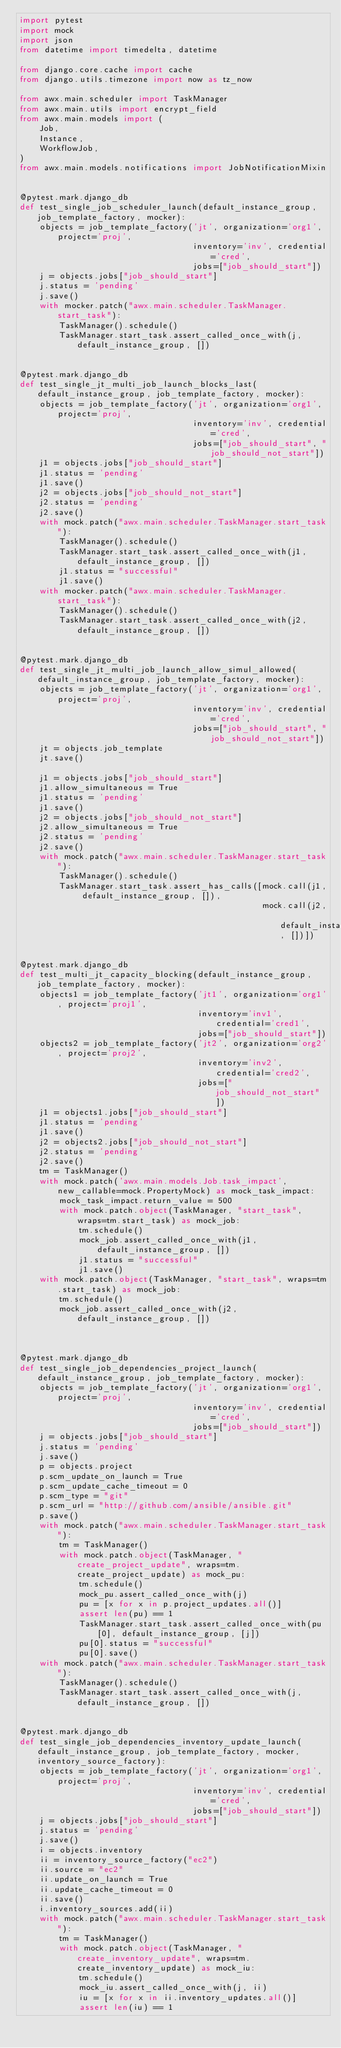<code> <loc_0><loc_0><loc_500><loc_500><_Python_>import pytest
import mock
import json
from datetime import timedelta, datetime

from django.core.cache import cache
from django.utils.timezone import now as tz_now

from awx.main.scheduler import TaskManager
from awx.main.utils import encrypt_field
from awx.main.models import (
    Job,
    Instance,
    WorkflowJob,
)
from awx.main.models.notifications import JobNotificationMixin


@pytest.mark.django_db
def test_single_job_scheduler_launch(default_instance_group, job_template_factory, mocker):
    objects = job_template_factory('jt', organization='org1', project='proj',
                                   inventory='inv', credential='cred',
                                   jobs=["job_should_start"])
    j = objects.jobs["job_should_start"]
    j.status = 'pending'
    j.save()
    with mocker.patch("awx.main.scheduler.TaskManager.start_task"):
        TaskManager().schedule()
        TaskManager.start_task.assert_called_once_with(j, default_instance_group, [])


@pytest.mark.django_db
def test_single_jt_multi_job_launch_blocks_last(default_instance_group, job_template_factory, mocker):
    objects = job_template_factory('jt', organization='org1', project='proj',
                                   inventory='inv', credential='cred',
                                   jobs=["job_should_start", "job_should_not_start"])
    j1 = objects.jobs["job_should_start"]
    j1.status = 'pending'
    j1.save()
    j2 = objects.jobs["job_should_not_start"]
    j2.status = 'pending'
    j2.save()
    with mock.patch("awx.main.scheduler.TaskManager.start_task"):
        TaskManager().schedule()
        TaskManager.start_task.assert_called_once_with(j1, default_instance_group, [])
        j1.status = "successful"
        j1.save()
    with mocker.patch("awx.main.scheduler.TaskManager.start_task"):
        TaskManager().schedule()
        TaskManager.start_task.assert_called_once_with(j2, default_instance_group, [])


@pytest.mark.django_db
def test_single_jt_multi_job_launch_allow_simul_allowed(default_instance_group, job_template_factory, mocker):
    objects = job_template_factory('jt', organization='org1', project='proj',
                                   inventory='inv', credential='cred',
                                   jobs=["job_should_start", "job_should_not_start"])
    jt = objects.job_template
    jt.save()

    j1 = objects.jobs["job_should_start"]
    j1.allow_simultaneous = True
    j1.status = 'pending'
    j1.save()
    j2 = objects.jobs["job_should_not_start"]
    j2.allow_simultaneous = True
    j2.status = 'pending'
    j2.save()
    with mock.patch("awx.main.scheduler.TaskManager.start_task"):
        TaskManager().schedule()
        TaskManager.start_task.assert_has_calls([mock.call(j1, default_instance_group, []),
                                                 mock.call(j2, default_instance_group, [])])


@pytest.mark.django_db
def test_multi_jt_capacity_blocking(default_instance_group, job_template_factory, mocker):
    objects1 = job_template_factory('jt1', organization='org1', project='proj1',
                                    inventory='inv1', credential='cred1',
                                    jobs=["job_should_start"])
    objects2 = job_template_factory('jt2', organization='org2', project='proj2',
                                    inventory='inv2', credential='cred2',
                                    jobs=["job_should_not_start"])
    j1 = objects1.jobs["job_should_start"]
    j1.status = 'pending'
    j1.save()
    j2 = objects2.jobs["job_should_not_start"]
    j2.status = 'pending'
    j2.save()
    tm = TaskManager()
    with mock.patch('awx.main.models.Job.task_impact', new_callable=mock.PropertyMock) as mock_task_impact:
        mock_task_impact.return_value = 500
        with mock.patch.object(TaskManager, "start_task", wraps=tm.start_task) as mock_job:
            tm.schedule()
            mock_job.assert_called_once_with(j1, default_instance_group, [])
            j1.status = "successful"
            j1.save()
    with mock.patch.object(TaskManager, "start_task", wraps=tm.start_task) as mock_job:
        tm.schedule()
        mock_job.assert_called_once_with(j2, default_instance_group, [])
    
    

@pytest.mark.django_db
def test_single_job_dependencies_project_launch(default_instance_group, job_template_factory, mocker):
    objects = job_template_factory('jt', organization='org1', project='proj',
                                   inventory='inv', credential='cred',
                                   jobs=["job_should_start"])
    j = objects.jobs["job_should_start"]
    j.status = 'pending'
    j.save()
    p = objects.project
    p.scm_update_on_launch = True
    p.scm_update_cache_timeout = 0
    p.scm_type = "git"
    p.scm_url = "http://github.com/ansible/ansible.git"
    p.save()
    with mock.patch("awx.main.scheduler.TaskManager.start_task"):
        tm = TaskManager()
        with mock.patch.object(TaskManager, "create_project_update", wraps=tm.create_project_update) as mock_pu:
            tm.schedule()
            mock_pu.assert_called_once_with(j)
            pu = [x for x in p.project_updates.all()]
            assert len(pu) == 1
            TaskManager.start_task.assert_called_once_with(pu[0], default_instance_group, [j])
            pu[0].status = "successful"
            pu[0].save()
    with mock.patch("awx.main.scheduler.TaskManager.start_task"):
        TaskManager().schedule()
        TaskManager.start_task.assert_called_once_with(j, default_instance_group, [])


@pytest.mark.django_db
def test_single_job_dependencies_inventory_update_launch(default_instance_group, job_template_factory, mocker, inventory_source_factory):
    objects = job_template_factory('jt', organization='org1', project='proj',
                                   inventory='inv', credential='cred',
                                   jobs=["job_should_start"])
    j = objects.jobs["job_should_start"]
    j.status = 'pending'
    j.save()
    i = objects.inventory
    ii = inventory_source_factory("ec2")
    ii.source = "ec2"
    ii.update_on_launch = True
    ii.update_cache_timeout = 0
    ii.save()
    i.inventory_sources.add(ii)
    with mock.patch("awx.main.scheduler.TaskManager.start_task"):
        tm = TaskManager()
        with mock.patch.object(TaskManager, "create_inventory_update", wraps=tm.create_inventory_update) as mock_iu:
            tm.schedule()
            mock_iu.assert_called_once_with(j, ii)
            iu = [x for x in ii.inventory_updates.all()]
            assert len(iu) == 1</code> 